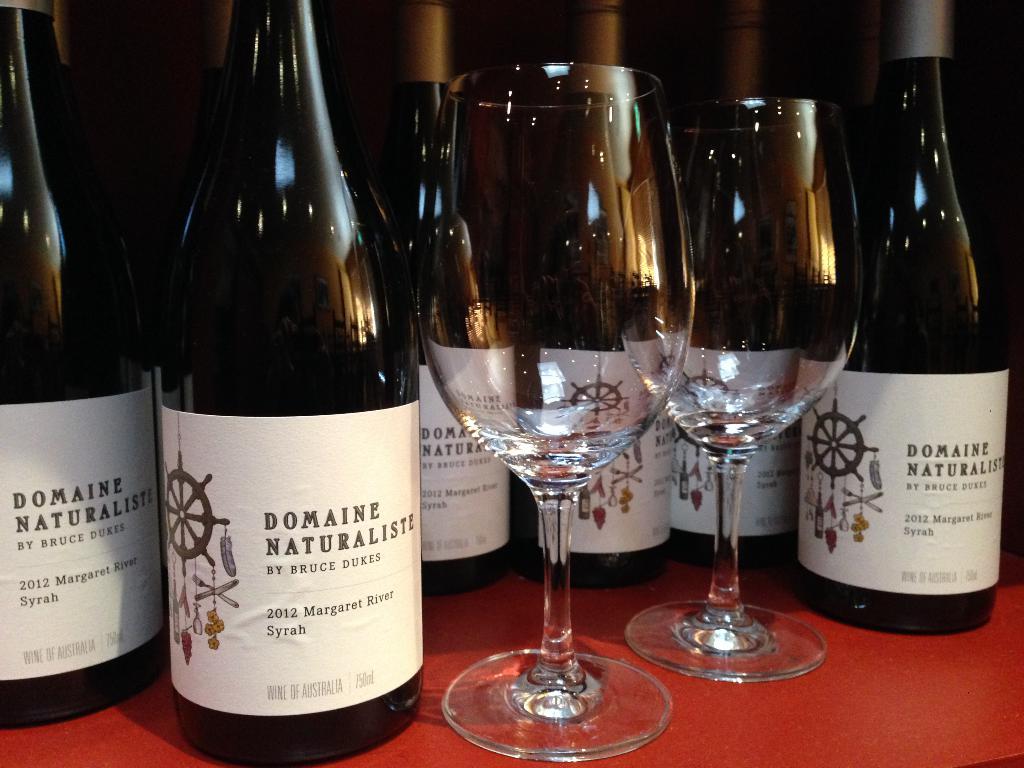What year was this wine made?
Your answer should be very brief. 2012. 